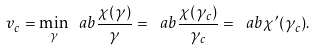Convert formula to latex. <formula><loc_0><loc_0><loc_500><loc_500>v _ { c } = \min _ { \gamma } \ a b \frac { \chi ( \gamma ) } { \gamma } = \ a b \frac { \chi ( \gamma _ { c } ) } { \gamma _ { c } } = \ a b \chi ^ { \prime } ( \gamma _ { c } ) .</formula> 